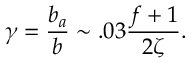<formula> <loc_0><loc_0><loc_500><loc_500>\gamma = \frac { b _ { a } } { b } \sim . 0 3 \frac { f + 1 } { 2 \zeta } .</formula> 